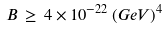Convert formula to latex. <formula><loc_0><loc_0><loc_500><loc_500>B \, \geq \, 4 \times 1 0 ^ { - 2 2 } \, ( G e V ) ^ { 4 }</formula> 